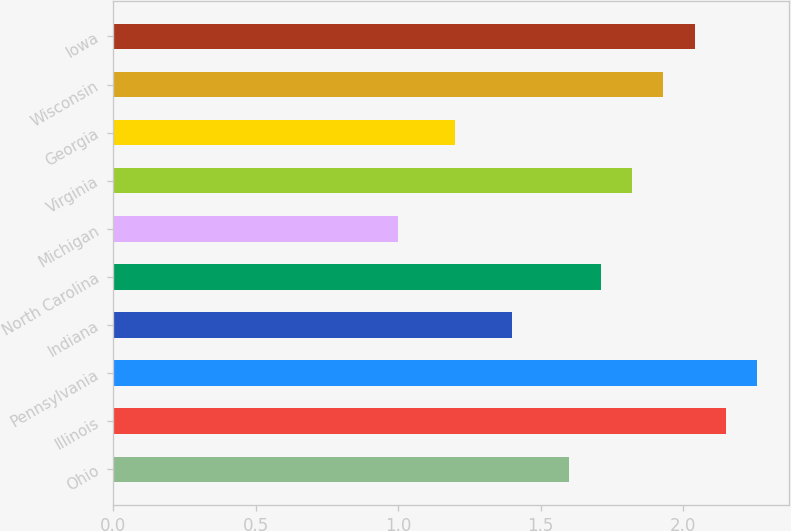Convert chart to OTSL. <chart><loc_0><loc_0><loc_500><loc_500><bar_chart><fcel>Ohio<fcel>Illinois<fcel>Pennsylvania<fcel>Indiana<fcel>North Carolina<fcel>Michigan<fcel>Virginia<fcel>Georgia<fcel>Wisconsin<fcel>Iowa<nl><fcel>1.6<fcel>2.15<fcel>2.26<fcel>1.4<fcel>1.71<fcel>1<fcel>1.82<fcel>1.2<fcel>1.93<fcel>2.04<nl></chart> 